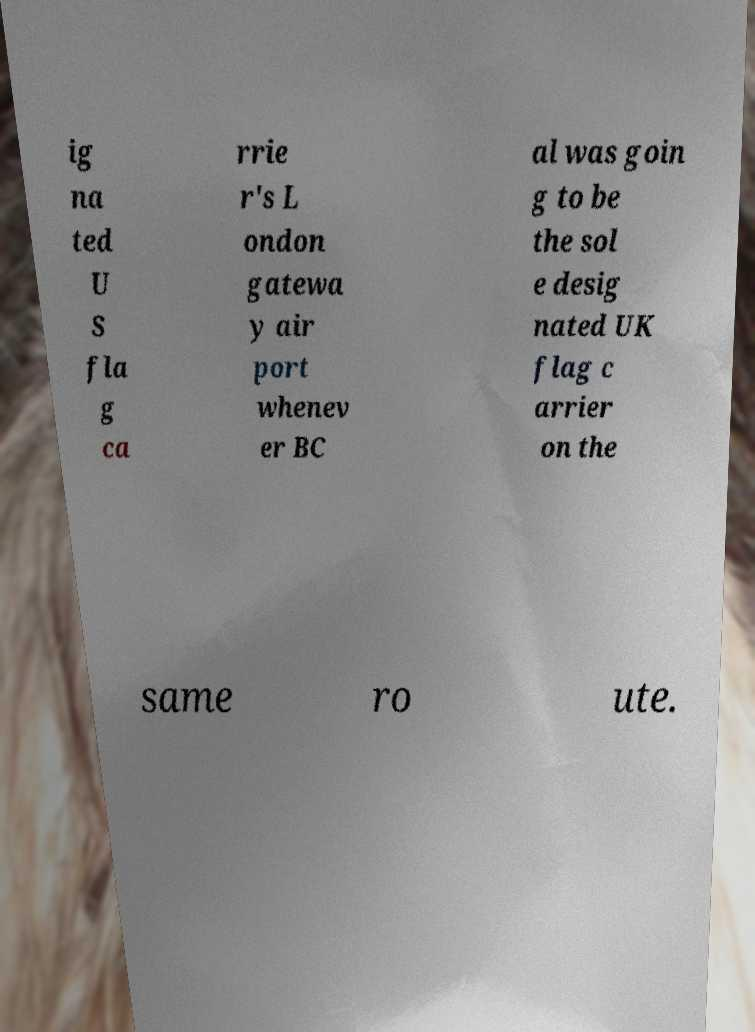I need the written content from this picture converted into text. Can you do that? ig na ted U S fla g ca rrie r's L ondon gatewa y air port whenev er BC al was goin g to be the sol e desig nated UK flag c arrier on the same ro ute. 